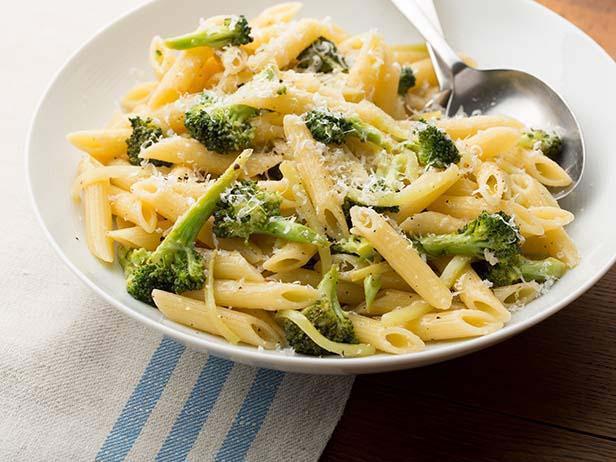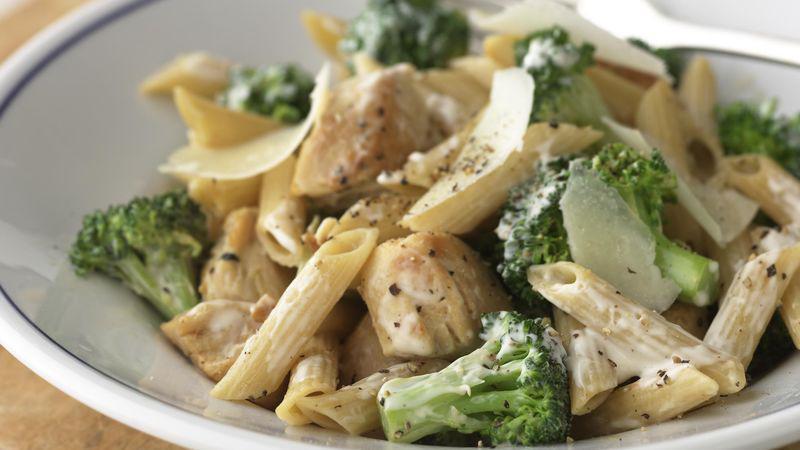The first image is the image on the left, the second image is the image on the right. For the images displayed, is the sentence "An image shows a round bowl of broccoli and pasta with a silver serving spoon inserted in it." factually correct? Answer yes or no. Yes. The first image is the image on the left, the second image is the image on the right. Given the left and right images, does the statement "The bowl in the image on the left is white and round." hold true? Answer yes or no. Yes. 